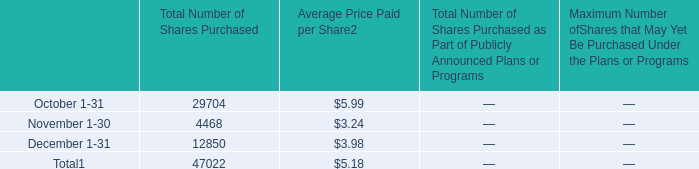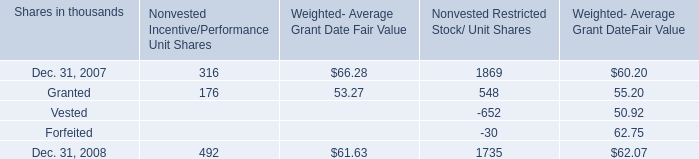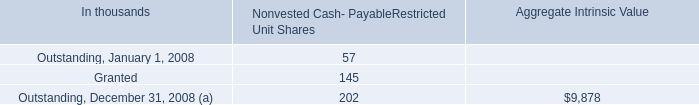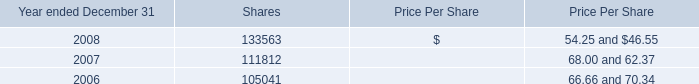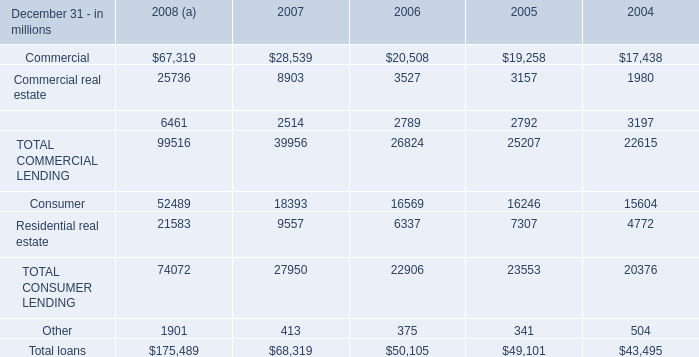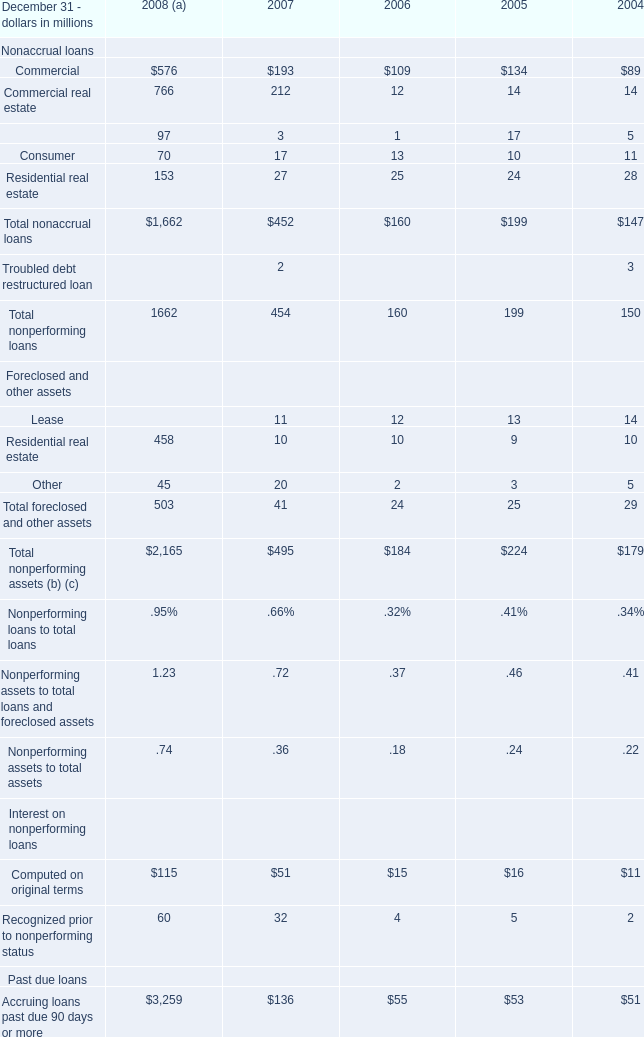What was the total amount of Foreclosed and other assets in the range of 0 and 15 in 2007 ？ (in million) 
Computations: (11 + 10)
Answer: 21.0. 